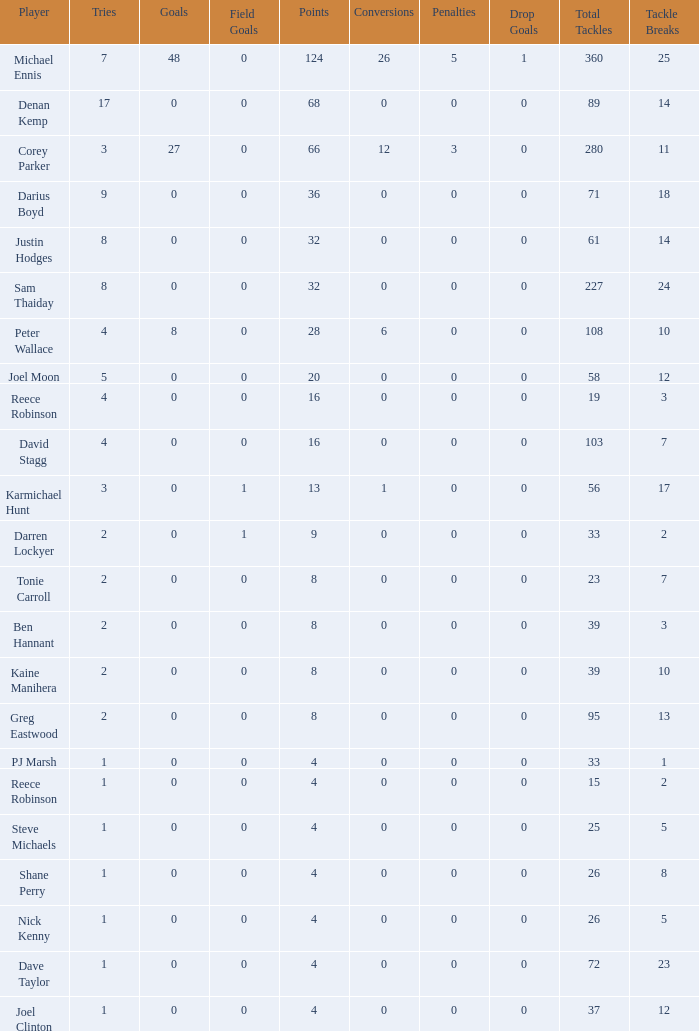What is the number of goals Dave Taylor, who has more than 1 tries, has? None. 